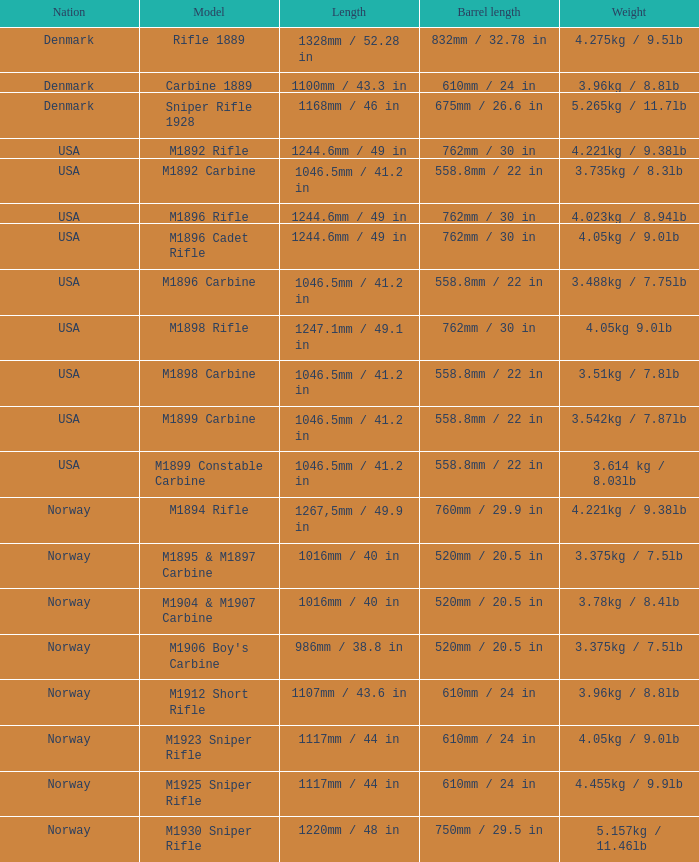What is Length, when Barrel Length is 750mm / 29.5 in? 1220mm / 48 in. 